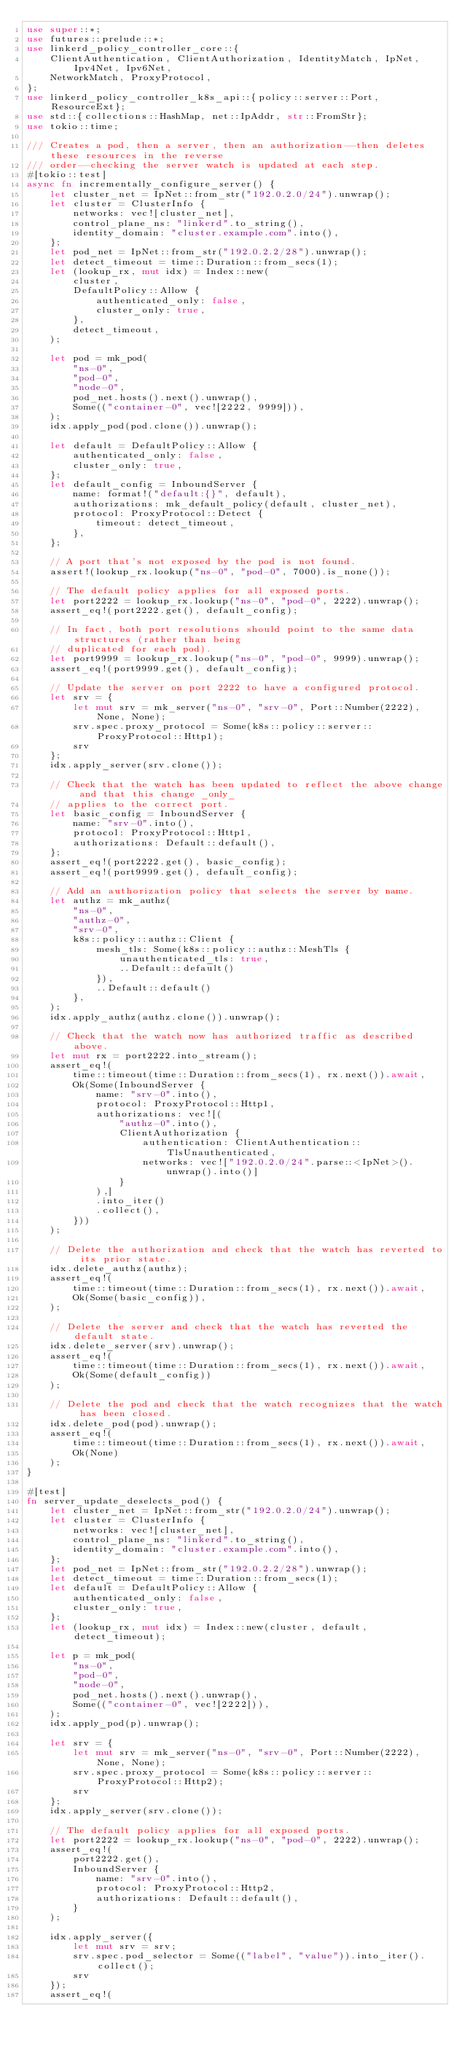<code> <loc_0><loc_0><loc_500><loc_500><_Rust_>use super::*;
use futures::prelude::*;
use linkerd_policy_controller_core::{
    ClientAuthentication, ClientAuthorization, IdentityMatch, IpNet, Ipv4Net, Ipv6Net,
    NetworkMatch, ProxyProtocol,
};
use linkerd_policy_controller_k8s_api::{policy::server::Port, ResourceExt};
use std::{collections::HashMap, net::IpAddr, str::FromStr};
use tokio::time;

/// Creates a pod, then a server, then an authorization--then deletes these resources in the reverse
/// order--checking the server watch is updated at each step.
#[tokio::test]
async fn incrementally_configure_server() {
    let cluster_net = IpNet::from_str("192.0.2.0/24").unwrap();
    let cluster = ClusterInfo {
        networks: vec![cluster_net],
        control_plane_ns: "linkerd".to_string(),
        identity_domain: "cluster.example.com".into(),
    };
    let pod_net = IpNet::from_str("192.0.2.2/28").unwrap();
    let detect_timeout = time::Duration::from_secs(1);
    let (lookup_rx, mut idx) = Index::new(
        cluster,
        DefaultPolicy::Allow {
            authenticated_only: false,
            cluster_only: true,
        },
        detect_timeout,
    );

    let pod = mk_pod(
        "ns-0",
        "pod-0",
        "node-0",
        pod_net.hosts().next().unwrap(),
        Some(("container-0", vec![2222, 9999])),
    );
    idx.apply_pod(pod.clone()).unwrap();

    let default = DefaultPolicy::Allow {
        authenticated_only: false,
        cluster_only: true,
    };
    let default_config = InboundServer {
        name: format!("default:{}", default),
        authorizations: mk_default_policy(default, cluster_net),
        protocol: ProxyProtocol::Detect {
            timeout: detect_timeout,
        },
    };

    // A port that's not exposed by the pod is not found.
    assert!(lookup_rx.lookup("ns-0", "pod-0", 7000).is_none());

    // The default policy applies for all exposed ports.
    let port2222 = lookup_rx.lookup("ns-0", "pod-0", 2222).unwrap();
    assert_eq!(port2222.get(), default_config);

    // In fact, both port resolutions should point to the same data structures (rather than being
    // duplicated for each pod).
    let port9999 = lookup_rx.lookup("ns-0", "pod-0", 9999).unwrap();
    assert_eq!(port9999.get(), default_config);

    // Update the server on port 2222 to have a configured protocol.
    let srv = {
        let mut srv = mk_server("ns-0", "srv-0", Port::Number(2222), None, None);
        srv.spec.proxy_protocol = Some(k8s::policy::server::ProxyProtocol::Http1);
        srv
    };
    idx.apply_server(srv.clone());

    // Check that the watch has been updated to reflect the above change and that this change _only_
    // applies to the correct port.
    let basic_config = InboundServer {
        name: "srv-0".into(),
        protocol: ProxyProtocol::Http1,
        authorizations: Default::default(),
    };
    assert_eq!(port2222.get(), basic_config);
    assert_eq!(port9999.get(), default_config);

    // Add an authorization policy that selects the server by name.
    let authz = mk_authz(
        "ns-0",
        "authz-0",
        "srv-0",
        k8s::policy::authz::Client {
            mesh_tls: Some(k8s::policy::authz::MeshTls {
                unauthenticated_tls: true,
                ..Default::default()
            }),
            ..Default::default()
        },
    );
    idx.apply_authz(authz.clone()).unwrap();

    // Check that the watch now has authorized traffic as described above.
    let mut rx = port2222.into_stream();
    assert_eq!(
        time::timeout(time::Duration::from_secs(1), rx.next()).await,
        Ok(Some(InboundServer {
            name: "srv-0".into(),
            protocol: ProxyProtocol::Http1,
            authorizations: vec![(
                "authz-0".into(),
                ClientAuthorization {
                    authentication: ClientAuthentication::TlsUnauthenticated,
                    networks: vec!["192.0.2.0/24".parse::<IpNet>().unwrap().into()]
                }
            ),]
            .into_iter()
            .collect(),
        }))
    );

    // Delete the authorization and check that the watch has reverted to its prior state.
    idx.delete_authz(authz);
    assert_eq!(
        time::timeout(time::Duration::from_secs(1), rx.next()).await,
        Ok(Some(basic_config)),
    );

    // Delete the server and check that the watch has reverted the default state.
    idx.delete_server(srv).unwrap();
    assert_eq!(
        time::timeout(time::Duration::from_secs(1), rx.next()).await,
        Ok(Some(default_config))
    );

    // Delete the pod and check that the watch recognizes that the watch has been closed.
    idx.delete_pod(pod).unwrap();
    assert_eq!(
        time::timeout(time::Duration::from_secs(1), rx.next()).await,
        Ok(None)
    );
}

#[test]
fn server_update_deselects_pod() {
    let cluster_net = IpNet::from_str("192.0.2.0/24").unwrap();
    let cluster = ClusterInfo {
        networks: vec![cluster_net],
        control_plane_ns: "linkerd".to_string(),
        identity_domain: "cluster.example.com".into(),
    };
    let pod_net = IpNet::from_str("192.0.2.2/28").unwrap();
    let detect_timeout = time::Duration::from_secs(1);
    let default = DefaultPolicy::Allow {
        authenticated_only: false,
        cluster_only: true,
    };
    let (lookup_rx, mut idx) = Index::new(cluster, default, detect_timeout);

    let p = mk_pod(
        "ns-0",
        "pod-0",
        "node-0",
        pod_net.hosts().next().unwrap(),
        Some(("container-0", vec![2222])),
    );
    idx.apply_pod(p).unwrap();

    let srv = {
        let mut srv = mk_server("ns-0", "srv-0", Port::Number(2222), None, None);
        srv.spec.proxy_protocol = Some(k8s::policy::server::ProxyProtocol::Http2);
        srv
    };
    idx.apply_server(srv.clone());

    // The default policy applies for all exposed ports.
    let port2222 = lookup_rx.lookup("ns-0", "pod-0", 2222).unwrap();
    assert_eq!(
        port2222.get(),
        InboundServer {
            name: "srv-0".into(),
            protocol: ProxyProtocol::Http2,
            authorizations: Default::default(),
        }
    );

    idx.apply_server({
        let mut srv = srv;
        srv.spec.pod_selector = Some(("label", "value")).into_iter().collect();
        srv
    });
    assert_eq!(</code> 